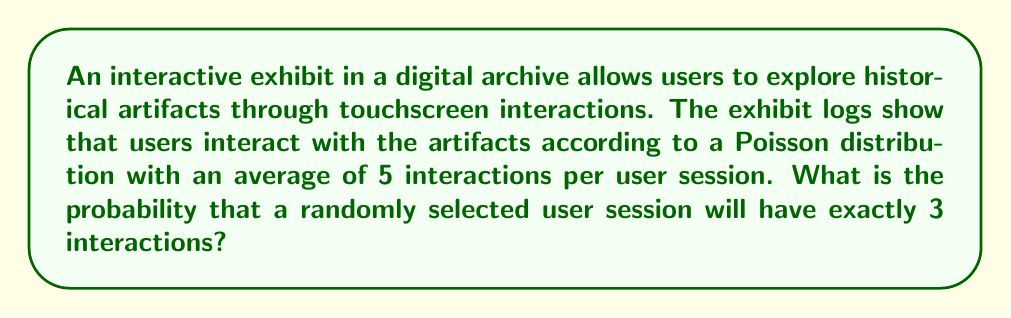Can you solve this math problem? To solve this problem, we'll use the Poisson probability mass function:

$$P(X = k) = \frac{e^{-\lambda} \lambda^k}{k!}$$

Where:
$\lambda$ = average number of events (interactions) per interval (user session)
$k$ = number of events (interactions) we're calculating the probability for
$e$ = Euler's number (approximately 2.71828)

Given:
$\lambda = 5$ (average interactions per session)
$k = 3$ (we want exactly 3 interactions)

Let's substitute these values into the formula:

$$P(X = 3) = \frac{e^{-5} 5^3}{3!}$$

Now, let's calculate step by step:

1) First, calculate $e^{-5}$:
   $e^{-5} \approx 0.00673795$

2) Calculate $5^3$:
   $5^3 = 125$

3) Calculate $3!$:
   $3! = 3 \times 2 \times 1 = 6$

4) Now, put it all together:
   $$P(X = 3) = \frac{0.00673795 \times 125}{6}$$

5) Simplify:
   $$P(X = 3) = \frac{0.842244}{6} \approx 0.140374$$

Therefore, the probability of a randomly selected user session having exactly 3 interactions is approximately 0.140374 or about 14.04%.
Answer: $0.140374$ or $14.04\%$ 